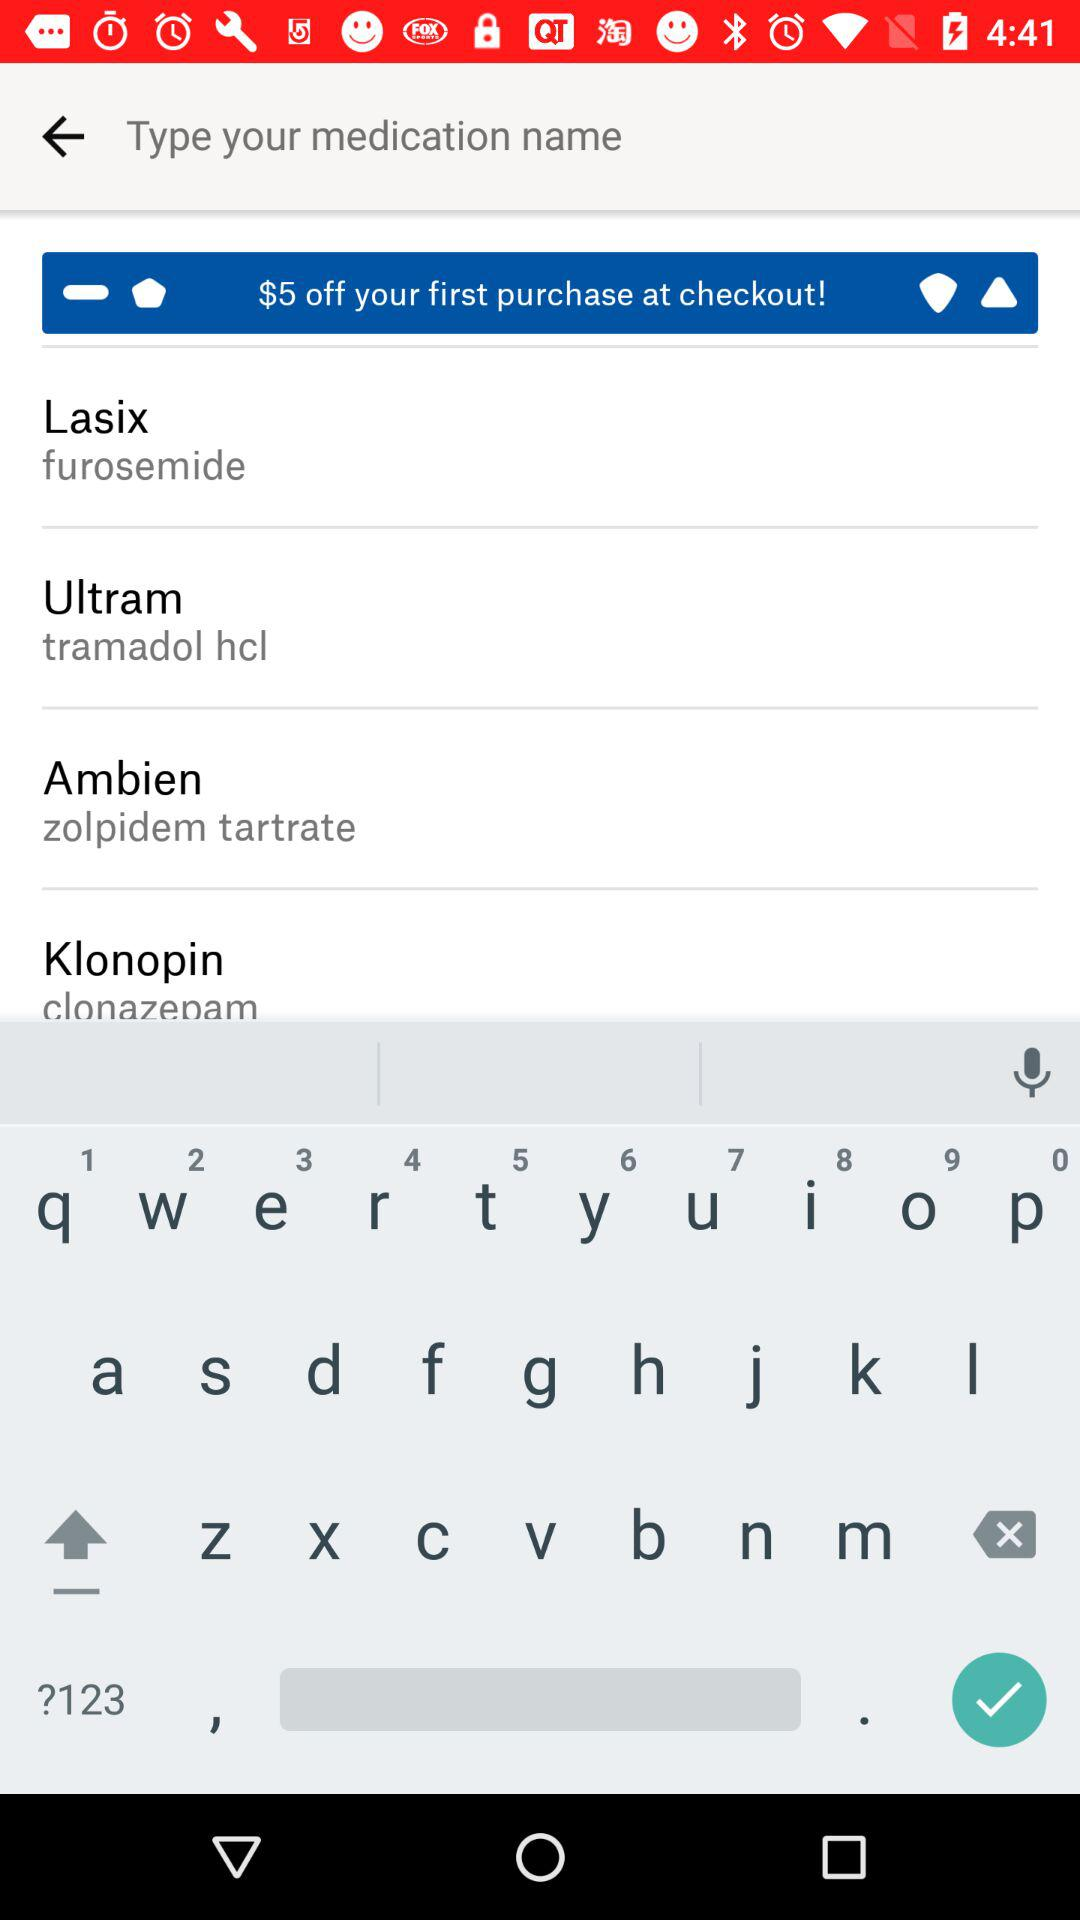How much is the average retail price for this medication?
Answer the question using a single word or phrase. $18.31 